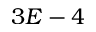<formula> <loc_0><loc_0><loc_500><loc_500>3 E - 4</formula> 